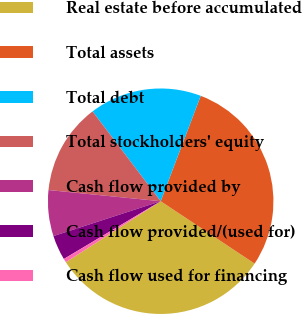Convert chart to OTSL. <chart><loc_0><loc_0><loc_500><loc_500><pie_chart><fcel>Real estate before accumulated<fcel>Total assets<fcel>Total debt<fcel>Total stockholders' equity<fcel>Cash flow provided by<fcel>Cash flow provided/(used for)<fcel>Cash flow used for financing<nl><fcel>31.57%<fcel>28.55%<fcel>16.11%<fcel>13.09%<fcel>6.58%<fcel>3.56%<fcel>0.54%<nl></chart> 